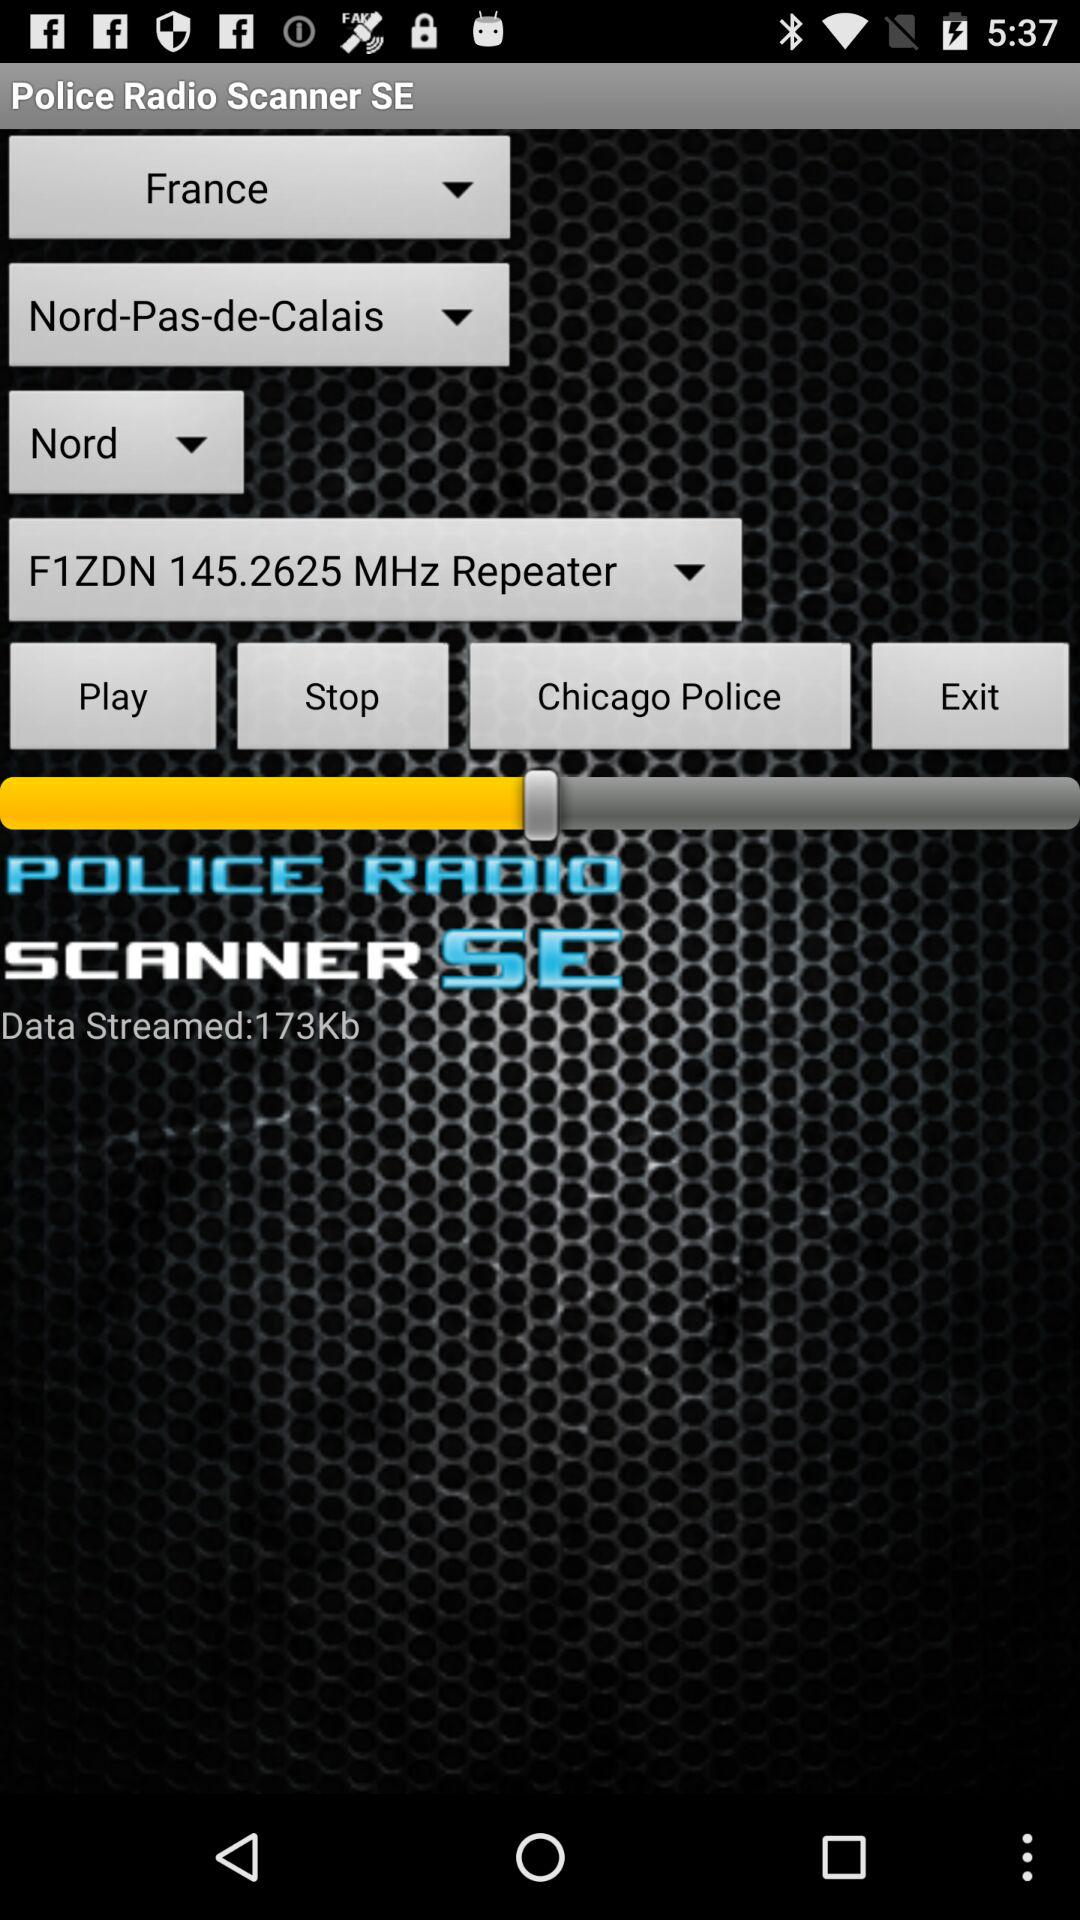What is the location? The location is Nord, Nord-Pas-de-Calais, France. 